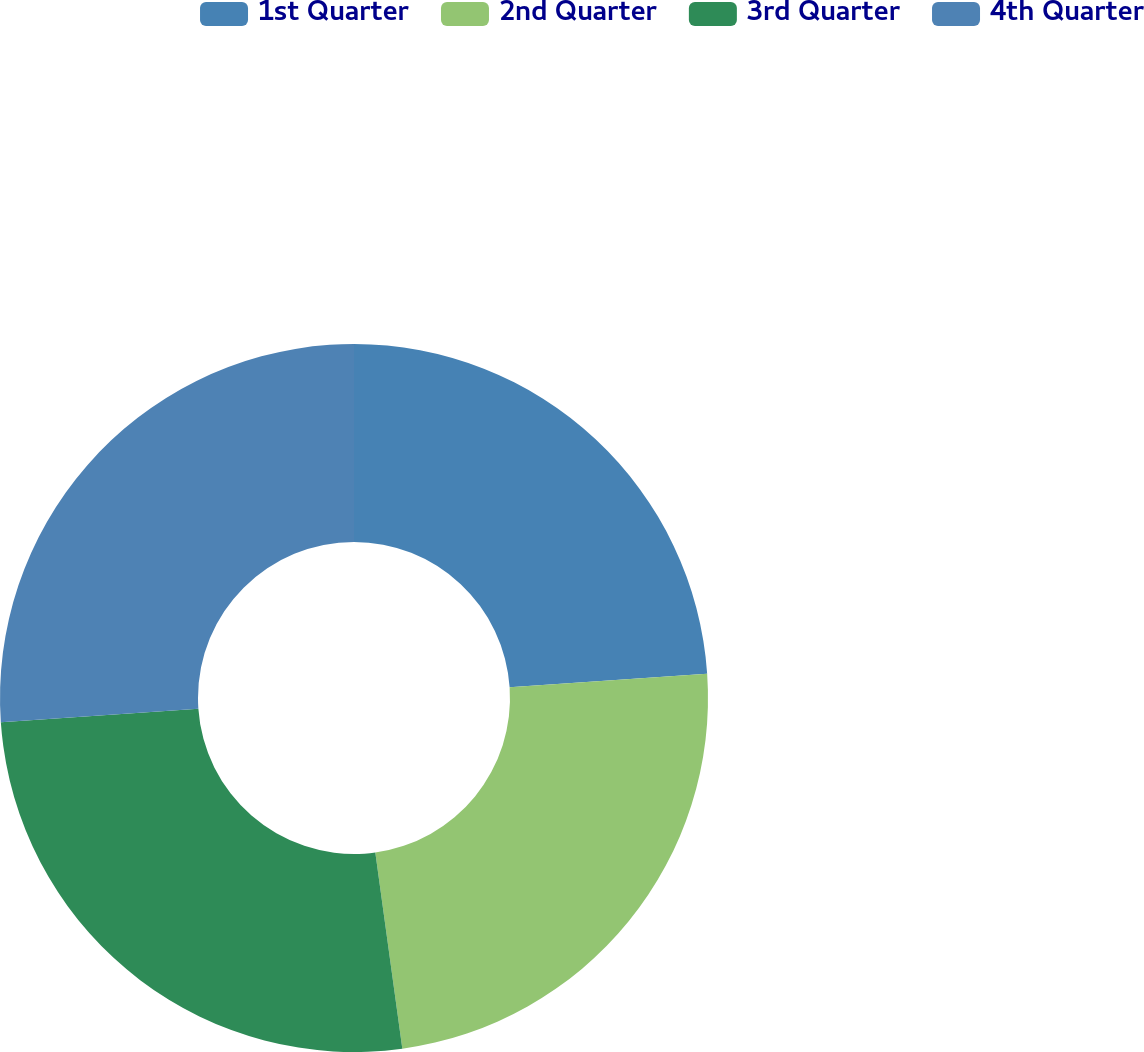<chart> <loc_0><loc_0><loc_500><loc_500><pie_chart><fcel>1st Quarter<fcel>2nd Quarter<fcel>3rd Quarter<fcel>4th Quarter<nl><fcel>23.91%<fcel>23.91%<fcel>26.09%<fcel>26.09%<nl></chart> 